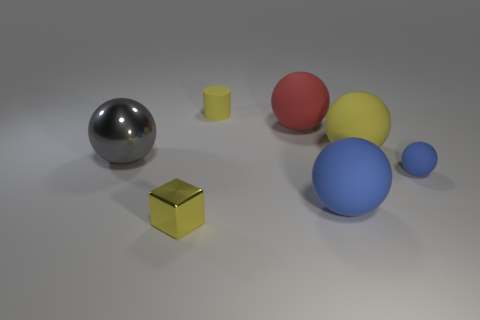What number of other objects are the same color as the small sphere?
Give a very brief answer. 1. How big is the yellow metal block?
Give a very brief answer. Small. What is the shape of the tiny object that is both in front of the gray metal ball and right of the yellow shiny thing?
Make the answer very short. Sphere. How many green objects are cylinders or small objects?
Provide a succinct answer. 0. Is the size of the red sphere behind the big yellow ball the same as the metal thing on the right side of the large metal object?
Give a very brief answer. No. What number of objects are either cylinders or small cyan cylinders?
Give a very brief answer. 1. Are there any red metallic objects of the same shape as the big yellow matte thing?
Offer a very short reply. No. Is the number of blue matte spheres less than the number of small gray metallic cubes?
Your response must be concise. No. Is the shape of the large yellow thing the same as the small yellow shiny object?
Provide a succinct answer. No. What number of objects are small metal things or balls that are behind the gray ball?
Provide a short and direct response. 3. 